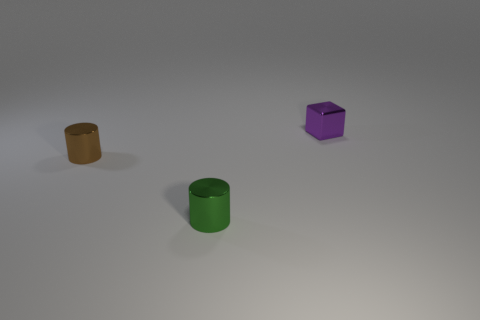Add 2 brown objects. How many objects exist? 5 Subtract all cylinders. How many objects are left? 1 Subtract all gray blocks. Subtract all purple cylinders. How many blocks are left? 1 Subtract all purple cubes. How many green cylinders are left? 1 Subtract all tiny green metal cylinders. Subtract all small brown objects. How many objects are left? 1 Add 2 tiny cubes. How many tiny cubes are left? 3 Add 1 green cylinders. How many green cylinders exist? 2 Subtract all brown cylinders. How many cylinders are left? 1 Subtract 0 gray blocks. How many objects are left? 3 Subtract 1 cylinders. How many cylinders are left? 1 